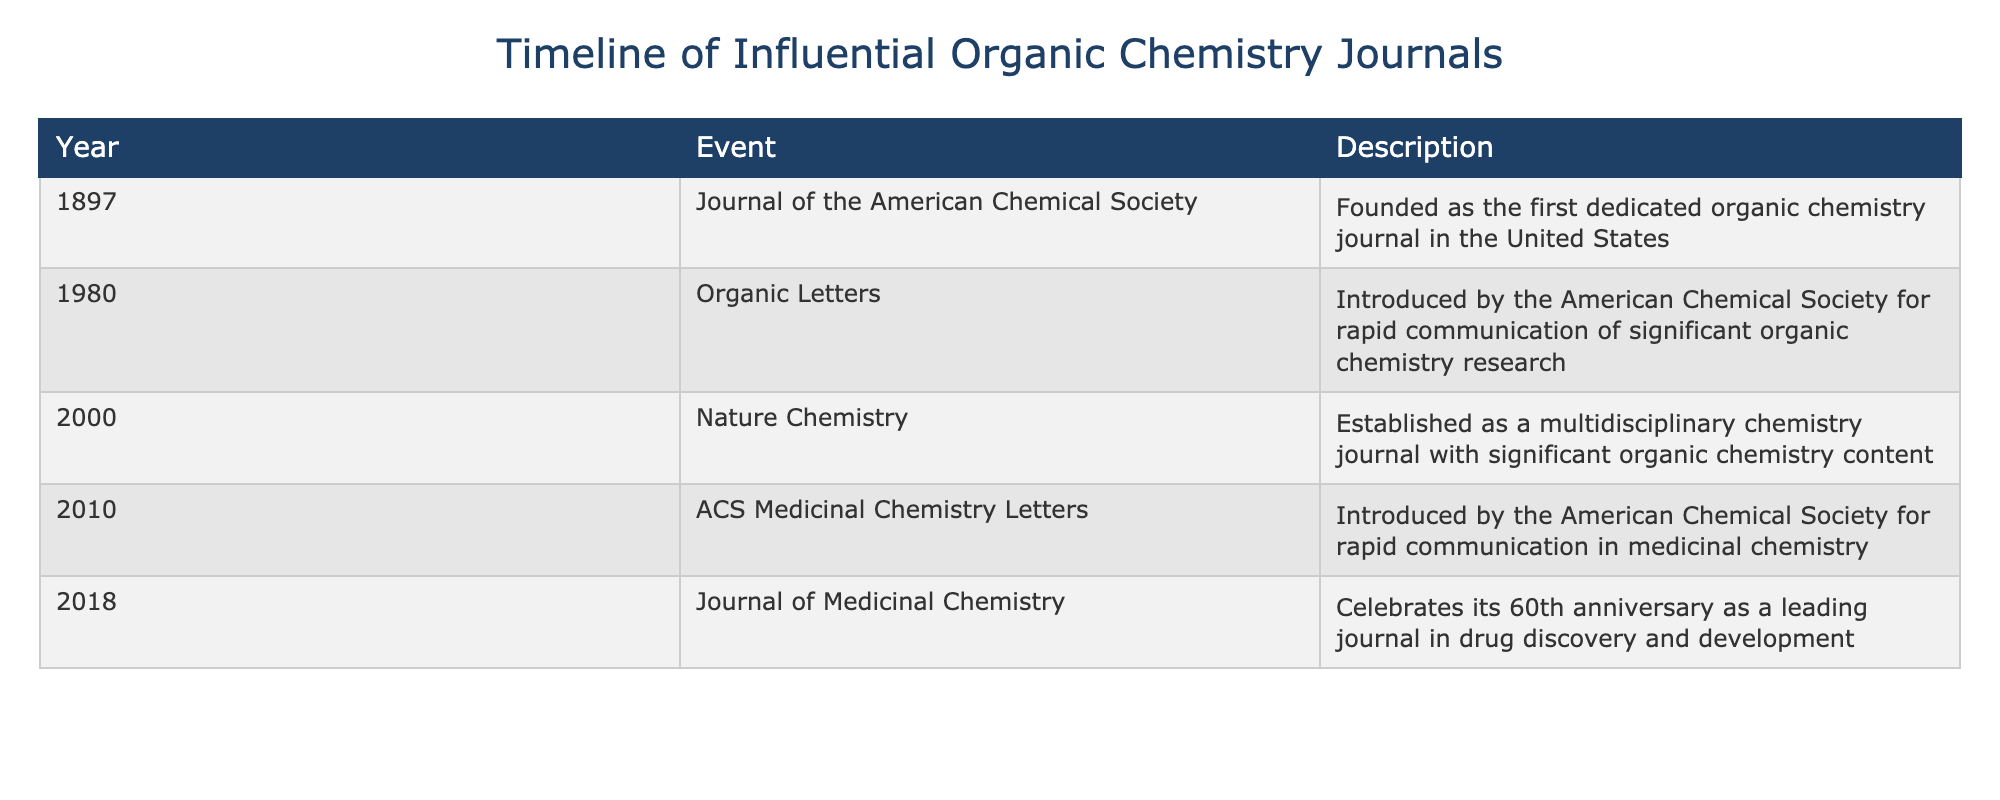What year was the Journal of the American Chemical Society founded? The table states that the Journal of the American Chemical Society was founded in 1897.
Answer: 1897 Which journal was founded for rapid communication of significant organic chemistry research? According to the table, Organic Letters was introduced in 1980 for rapid communication of significant organic chemistry research.
Answer: Organic Letters How many years apart were the founding of the Journal of the American Chemical Society and Organic Letters? The Journal of the American Chemical Society was founded in 1897 and Organic Letters was introduced in 1980. The difference between 1980 and 1897 is 83 years.
Answer: 83 years Is Nature Chemistry a multidisciplinary chemistry journal with significant organic chemistry content? Yes, the table indicates that Nature Chemistry was established as a multidisciplinary chemistry journal with significant organic chemistry content in 2000.
Answer: Yes What is the significance of the year 2010 in this timeline? The year 2010 marks the introduction of ACS Medicinal Chemistry Letters, which is a journal for rapid communication in medicinal chemistry according to the table.
Answer: Introduction of ACS Medicinal Chemistry Letters What can you say about the milestones of influential organic chemistry journals from the provided years? The timeline shows that journals such as the Journal of the American Chemical Society (1897), Organic Letters (1980), and others were introduced at significant intervals spanning over a century, indicating the evolution and expansion of organic chemistry literature.
Answer: Evolution of organic chemistry literature How many journals were introduced after the year 2000? From the table, Nature Chemistry (2000), ACS Medicinal Chemistry Letters (2010), and the 60th anniversary of the Journal of Medicinal Chemistry (2018) indicate a total of three distinct journal events occurring after 2000.
Answer: Three journals What is the average year of introduction for the journals listed in the table? The years of introduction are 1897, 1980, 2000, 2010, and 2018. The average is calculated by summing these years (1897 + 1980 + 2000 + 2010 + 2018 = 9,905) and dividing by 5, which equals 1,981. Therefore, the average year is approximately 1998.2.
Answer: 1998.2 Did the Journal of Medicinal Chemistry celebrate an anniversary in the timeline? Yes, the table notes that the Journal of Medicinal Chemistry celebrated its 60th anniversary in 2018, indicating a significant milestone in its publication history.
Answer: Yes 